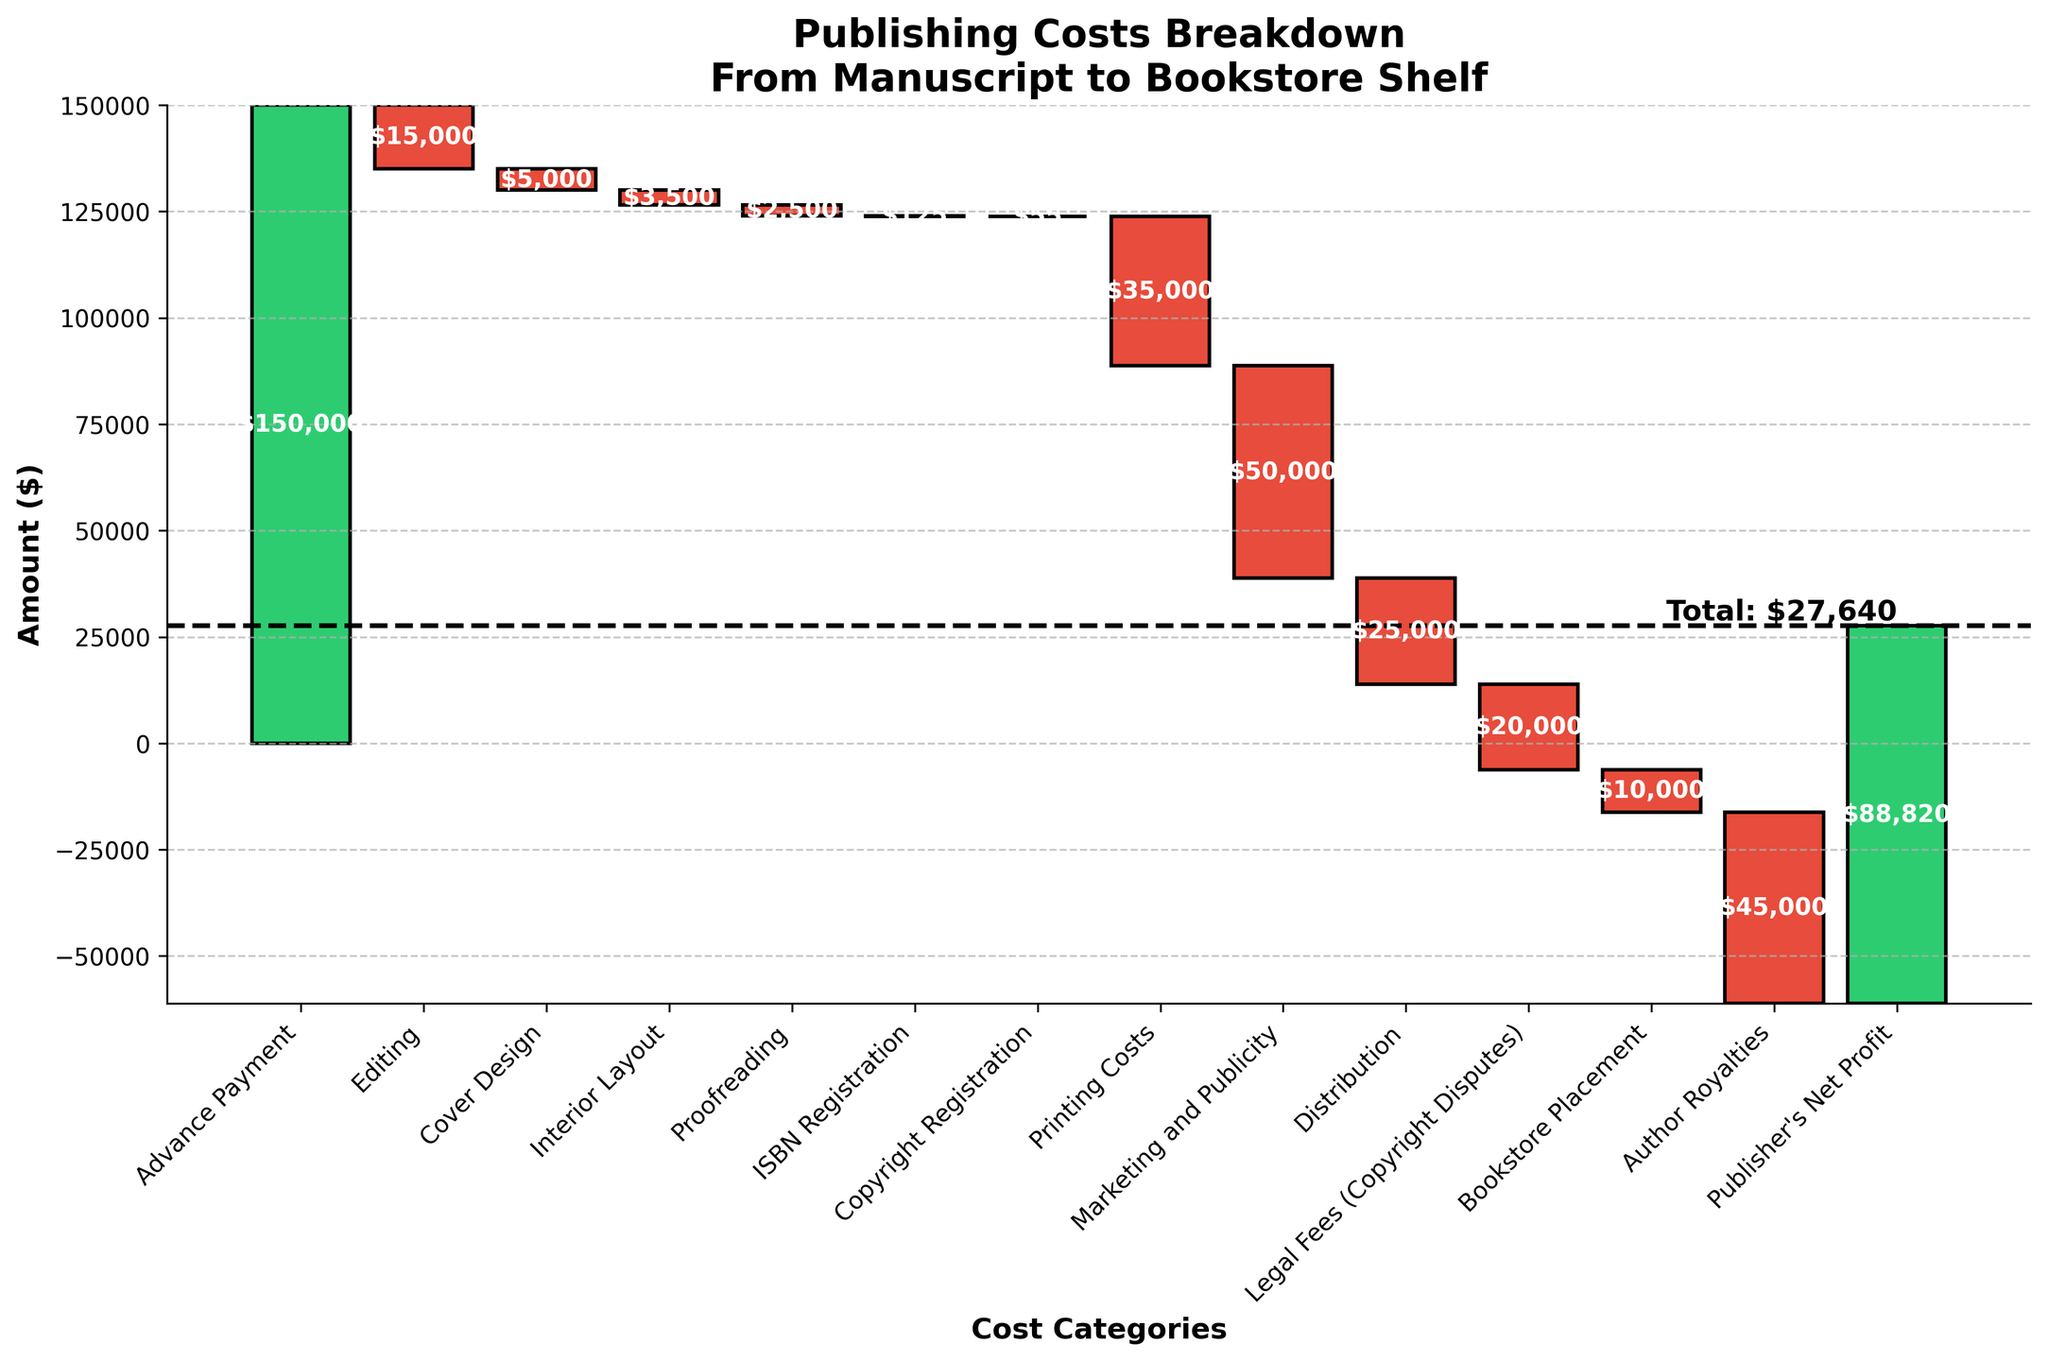What's the title of the figure? The title of the figure is found at the top and reads "Publishing Costs Breakdown From Manuscript to Bookstore Shelf".
Answer: Publishing Costs Breakdown From Manuscript to Bookstore Shelf How many cost categories are depicted in the figure? The number of cost categories can be determined by counting the labels on the x-axis, ranging from 'Advance Payment' to 'Publisher's Net Profit'.
Answer: 13 What is the total value for "Advance Payment"? The total value for "Advance Payment" can be read directly from the label on the bar associated with this category.
Answer: $150,000 How much more was spent on "Marketing and Publicity" compared to "Editing"? The value for "Marketing and Publicity" is $50,000 and "Editing" is $15,000. Subtract the latter from the former to find the difference.
Answer: $35,000 What is the cumulative amount after "Printing Costs"? To determine this, sum up all values from the beginning up to and including "Printing Costs" ($150,000 - $15,000 - $5,000 - $3,500 - $2,500 - $125 - $55 - $35,000).
Answer: $88,795 How does "Author Royalties" compare to "Bookstore Placement"? To compare these categories, look at their respective negative values: "Author Royalties" (-$45,000) is greater than "Bookstore Placement" (-$10,000).
Answer: -$45,000 is greater than -$10,000 Which category contributes the least to the total cost? By examining the values provided for every category, "Copyright Registration" has the smallest cost.
Answer: Copyright Registration What is the net value in the "Publisher's Net Profit" category? The value can be read directly from the label of the "Publisher's Net Profit" bar, which is the final cumulative amount depicted on the chart.
Answer: $88,820 How much is spent in total on "Legal Fees (Copyright Disputes)" and "Distribution"? Sum the values of "Legal Fees (Copyright Disputes)" (-$20,000) and "Distribution" (-$25,000).
Answer: $45,000 Is there a category where cumulative cost briefly turns positive after multiple negative values? By following the progression of values and their impact on cumulative cost, one can see that "Advance Payment" initially raises the total significantly before expenditure categories reduce it again.
Answer: Yes, Advance Payment 